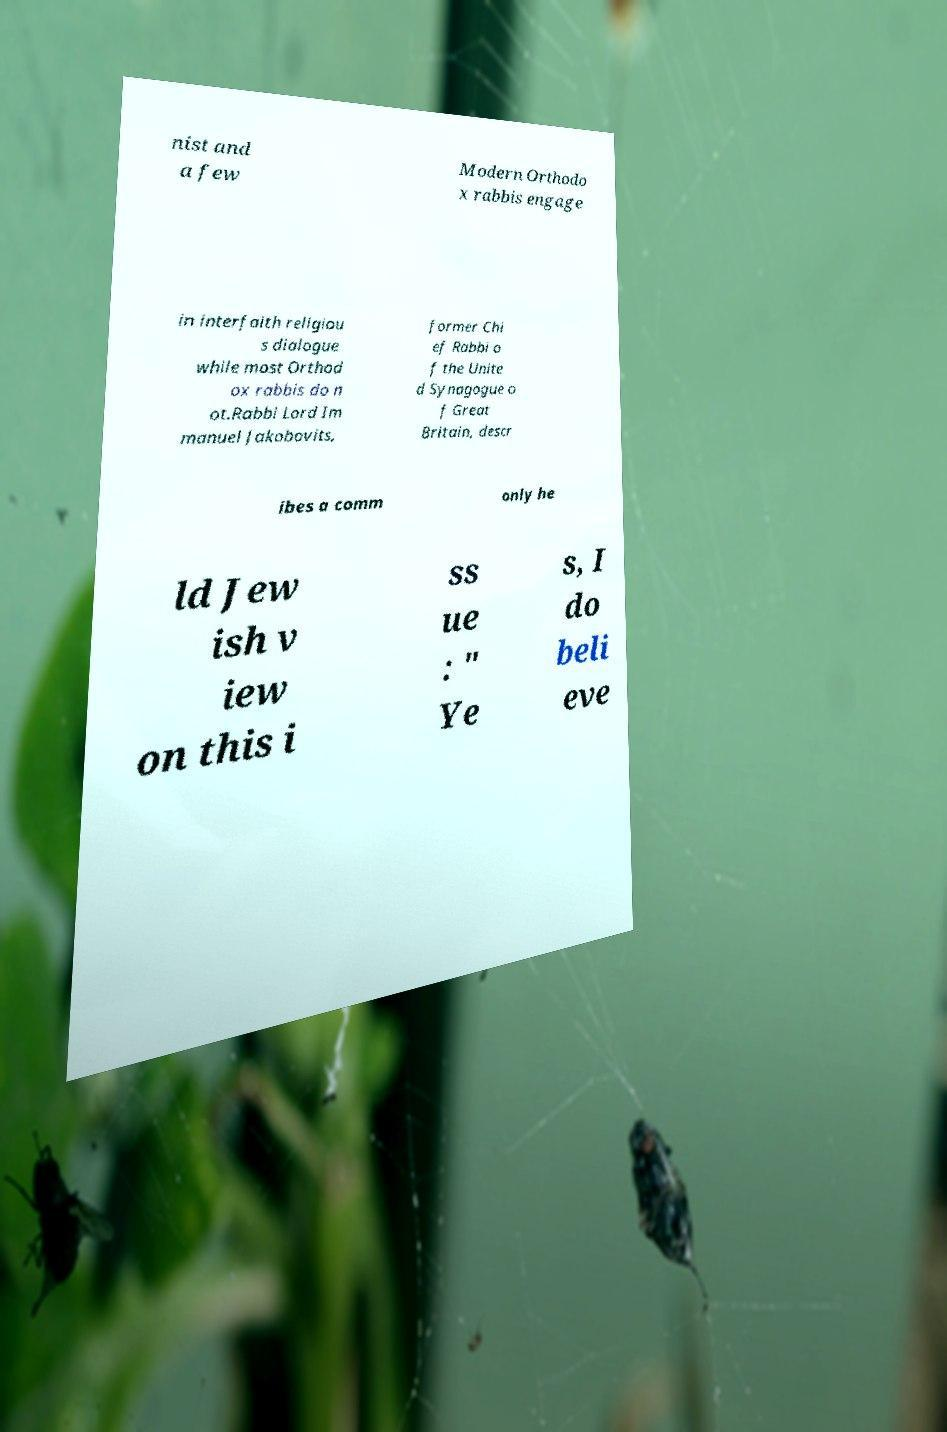Could you extract and type out the text from this image? nist and a few Modern Orthodo x rabbis engage in interfaith religiou s dialogue while most Orthod ox rabbis do n ot.Rabbi Lord Im manuel Jakobovits, former Chi ef Rabbi o f the Unite d Synagogue o f Great Britain, descr ibes a comm only he ld Jew ish v iew on this i ss ue : " Ye s, I do beli eve 